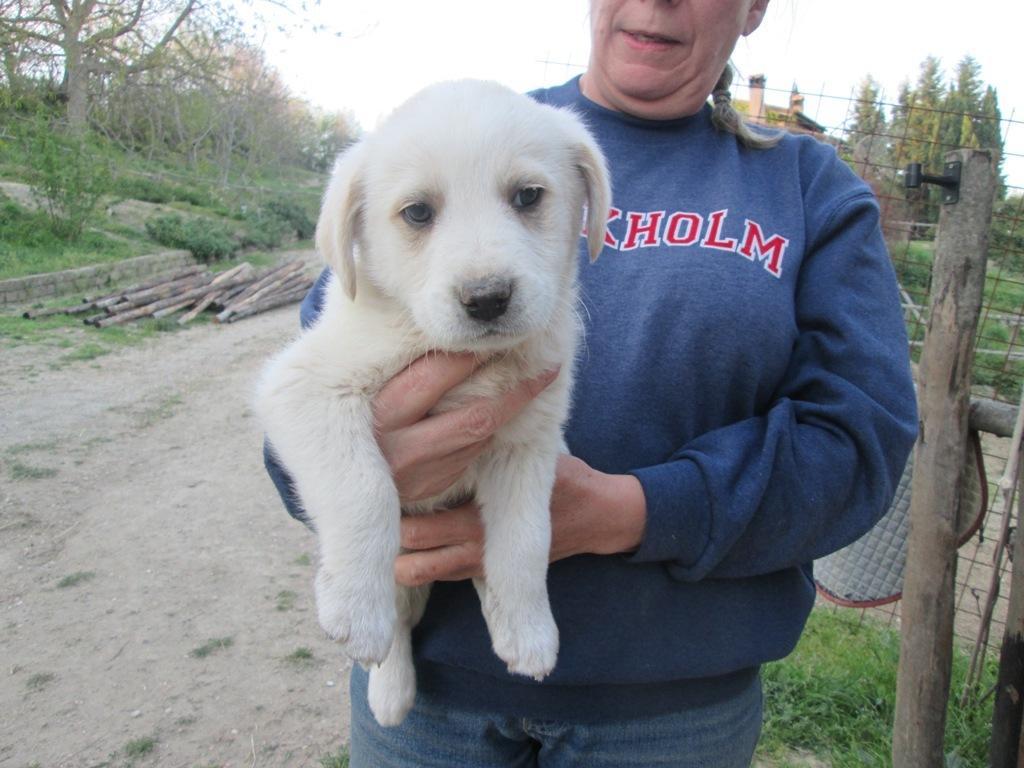Describe this image in one or two sentences. Here in this picture we can see a person holding a puppy in her hand and behind her we can see a fencing present and we can see wooden poles and sticks present over there and we can see plants and trees present all over there. 